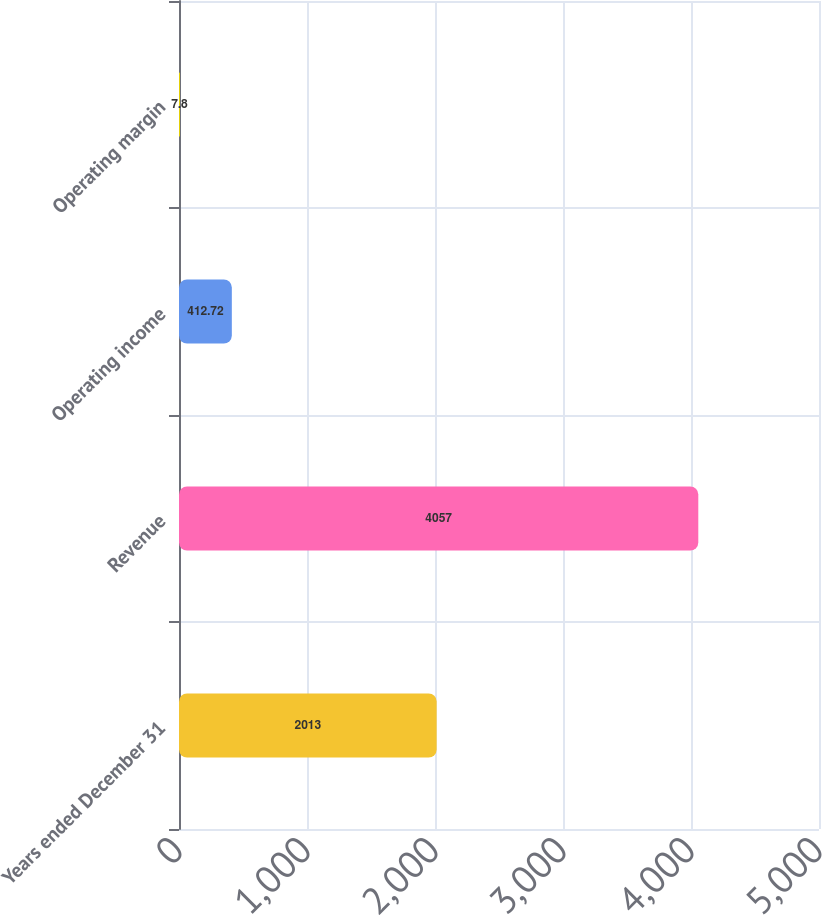Convert chart. <chart><loc_0><loc_0><loc_500><loc_500><bar_chart><fcel>Years ended December 31<fcel>Revenue<fcel>Operating income<fcel>Operating margin<nl><fcel>2013<fcel>4057<fcel>412.72<fcel>7.8<nl></chart> 